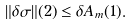Convert formula to latex. <formula><loc_0><loc_0><loc_500><loc_500>\| \delta \sigma \| ( 2 ) \leq \delta A _ { m } ( 1 ) .</formula> 